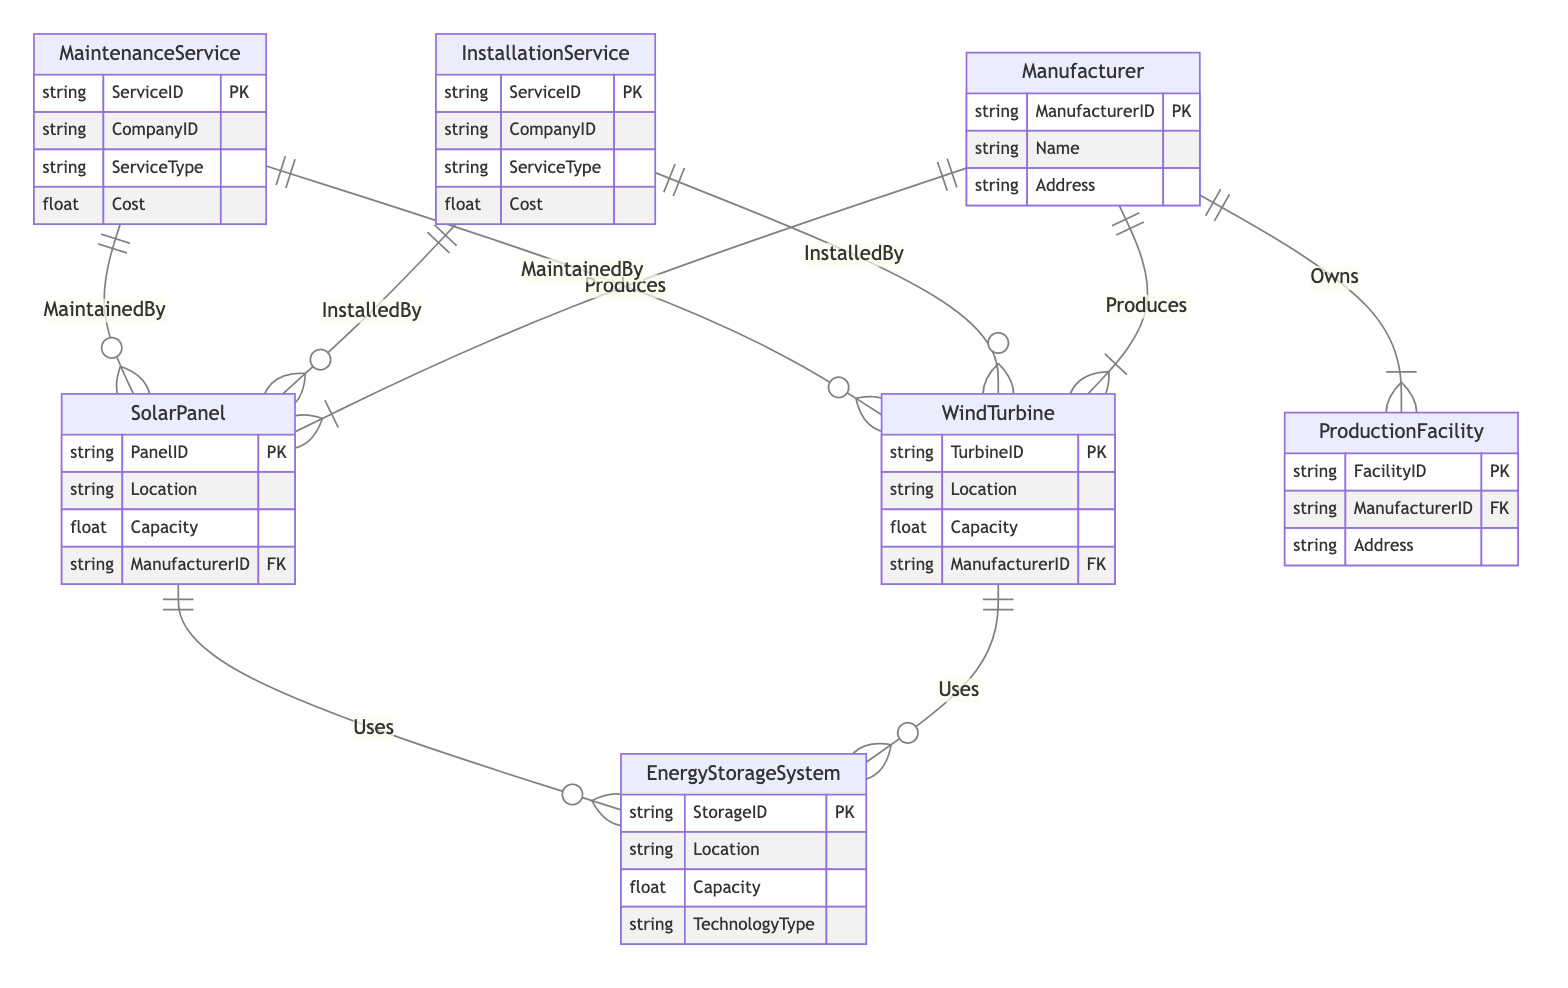What entities are produced by a manufacturer? In the diagram, the relationships labeled "Produces" connect the "Manufacturer" entity to "WindTurbine" and "SolarPanel." This indicates that a manufacturer produces these two types of renewable energy technologies.
Answer: Wind Turbine, Solar Panel How many types of services are there in the diagram? The diagram includes two types of services: "InstallationService" and "MaintenanceService," both represented as entities. Thus, there are a total of two service types.
Answer: Two What relationship connects an energy storage system to solar panels? The "Uses" relationship connects the "SolarPanel" entity to the "EnergyStorageSystem" entity, indicating that a solar panel uses the energy storage system.
Answer: Uses Which entity has the attribute "ManufacturerID"? The attributes listed for the "WindTurbine," "SolarPanel," and "ProductionFacility" entities all include "ManufacturerID." This signifies that these entities have a connection to the manufacturer.
Answer: Wind Turbine, Solar Panel, Production Facility What type of connection does a wind turbine have with an installation service? The "InstalledBy" relationship indicates how a "WindTurbine" entity connects to the "InstallationService" entity, showing that installation services are provided for wind turbines.
Answer: Installed By How many relationships involve solar panels? The diagram includes three relationship types involving solar panels: "Produces" with "Manufacturer," "Uses" with "EnergyStorageSystem," and "InstalledBy" with "InstallationService." Adding these together, solar panels interact with three relationships.
Answer: Three What is the primary function of the "Manufacturer" entity in the diagram? The "Manufacturer" entity primarily serves to produce renewable energy technologies, specifically "WindTurbine" and "SolarPanel," as illustrated by the relationships.
Answer: Produces What attributes do the energy storage systems possess? The "EnergyStorageSystem" entity includes the attributes: "StorageID," "Location," "Capacity," and "TechnologyType," which are characteristics describing the storage systems.
Answer: StorageID, Location, Capacity, TechnologyType Which service type is linked with maintenance of wind turbines? The "MaintainedBy" relationship links "WindTurbine" and "MaintenanceService," indicating that maintenance services are specifically tasked with maintaining wind turbines.
Answer: Maintained By 